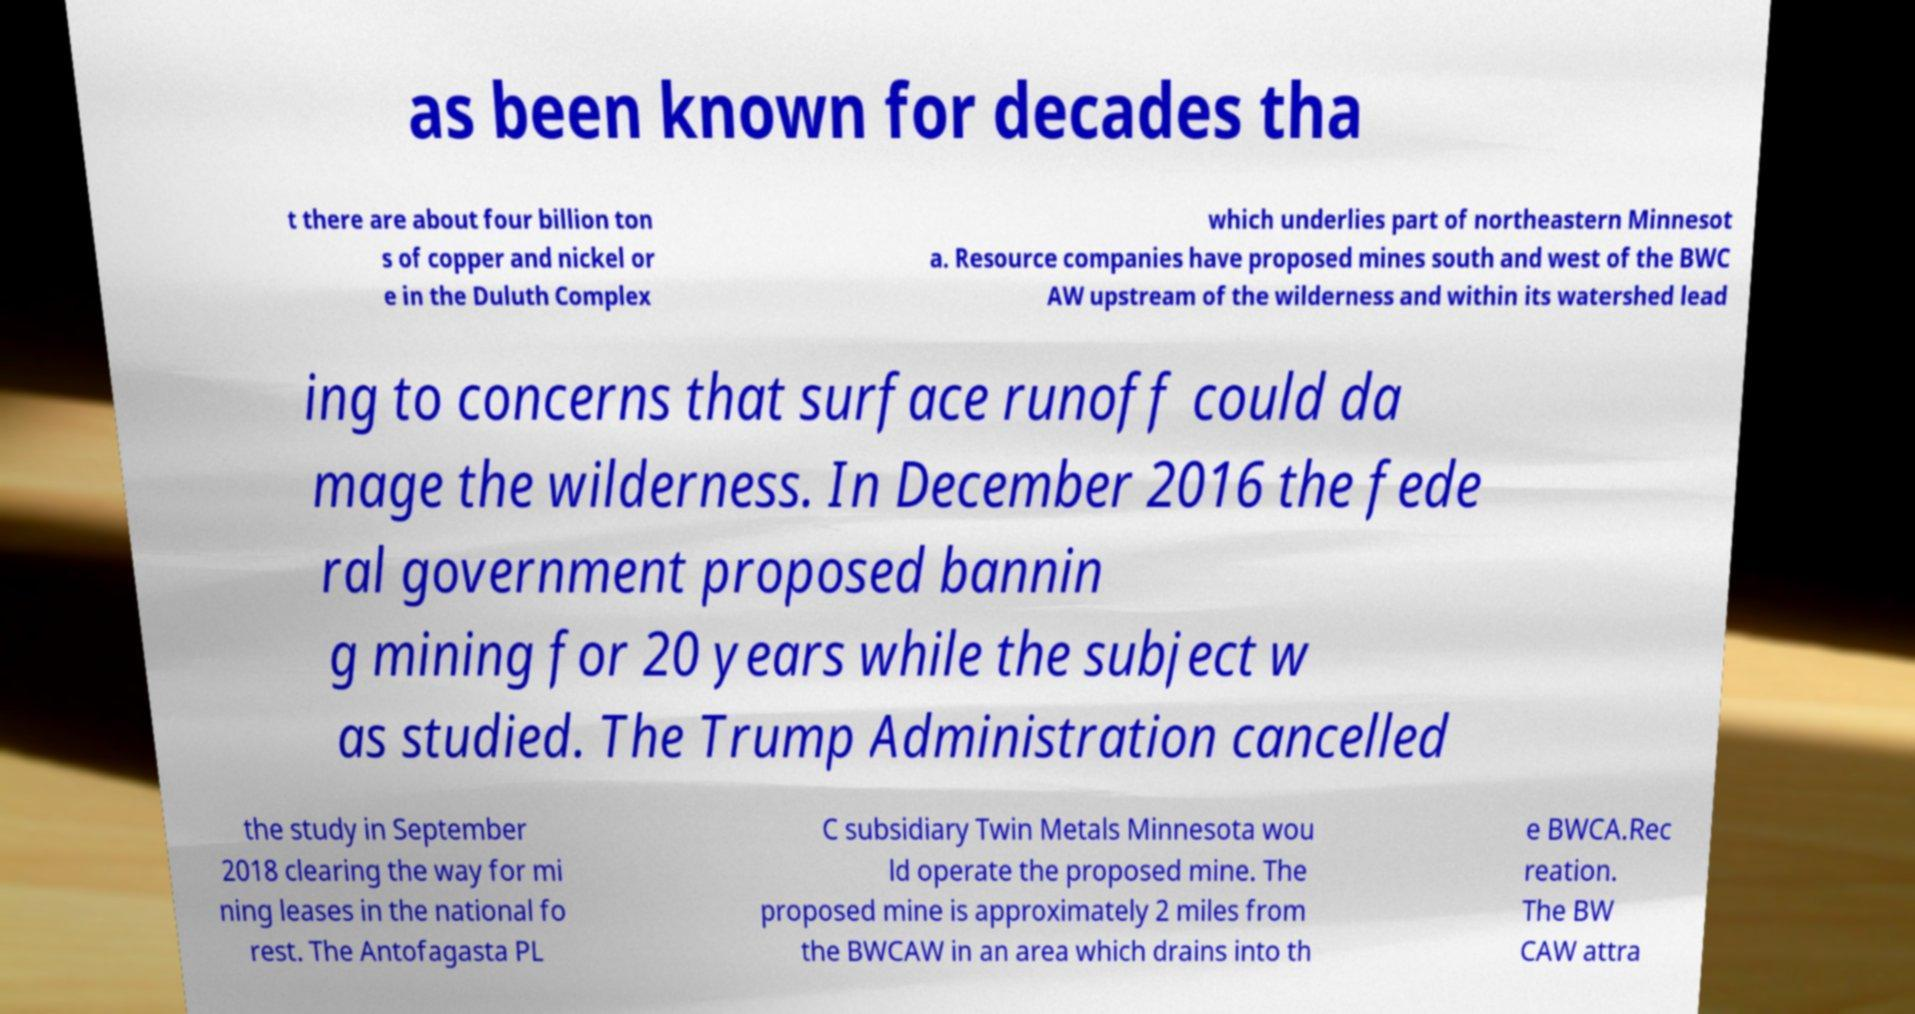Can you read and provide the text displayed in the image?This photo seems to have some interesting text. Can you extract and type it out for me? as been known for decades tha t there are about four billion ton s of copper and nickel or e in the Duluth Complex which underlies part of northeastern Minnesot a. Resource companies have proposed mines south and west of the BWC AW upstream of the wilderness and within its watershed lead ing to concerns that surface runoff could da mage the wilderness. In December 2016 the fede ral government proposed bannin g mining for 20 years while the subject w as studied. The Trump Administration cancelled the study in September 2018 clearing the way for mi ning leases in the national fo rest. The Antofagasta PL C subsidiary Twin Metals Minnesota wou ld operate the proposed mine. The proposed mine is approximately 2 miles from the BWCAW in an area which drains into th e BWCA.Rec reation. The BW CAW attra 